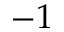<formula> <loc_0><loc_0><loc_500><loc_500>- 1</formula> 